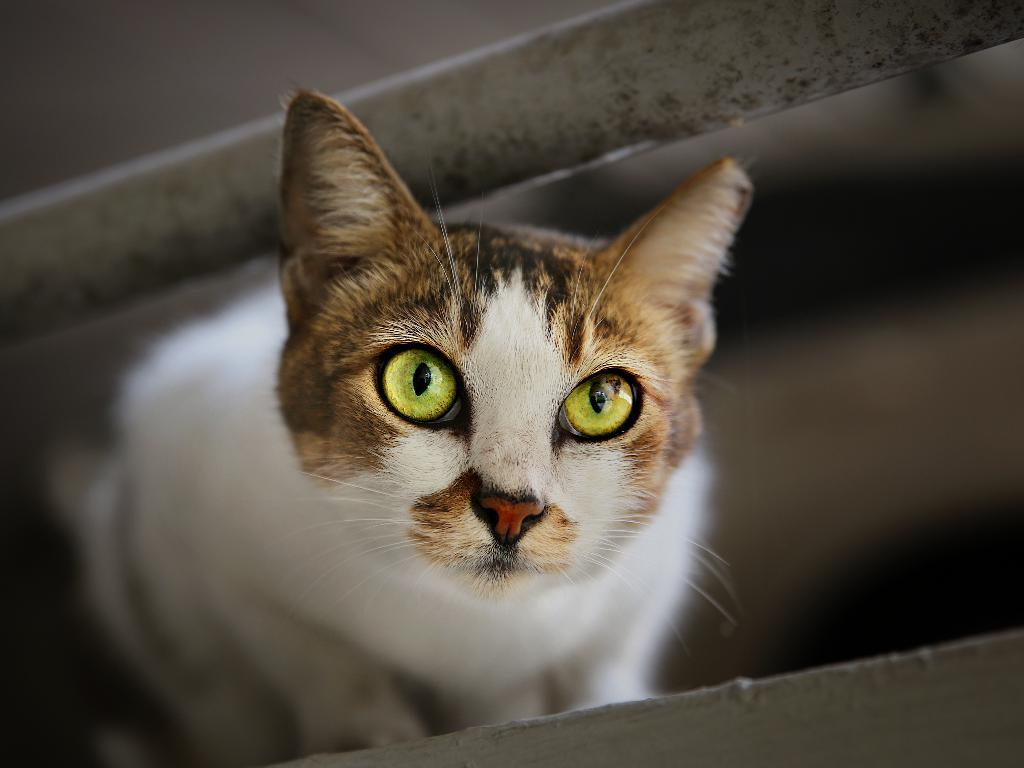What type of animal is in the image? There is a cat in the image. Can you describe the color pattern of the cat? The cat is white, brown, and black in color. What can be observed about the background of the image? The background of the image is blurred. Where is the nearest store to the cat in the image? There is no information about a store or its location in the image. How many snakes are visible in the image? There are no snakes present in the image. 